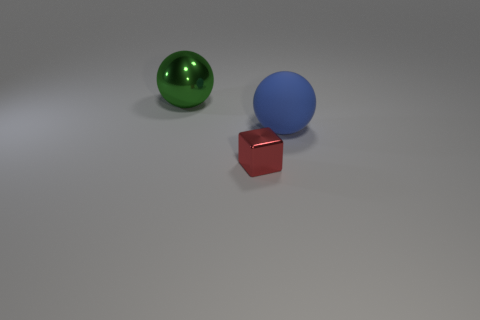What number of green things are large matte objects or big shiny objects?
Offer a very short reply. 1. How many things are both in front of the large metallic object and behind the tiny cube?
Give a very brief answer. 1. Is the material of the red block the same as the green sphere?
Provide a short and direct response. Yes. There is a metallic object that is the same size as the blue ball; what shape is it?
Offer a terse response. Sphere. Are there more tiny cyan metallic objects than green metal spheres?
Offer a very short reply. No. There is a thing that is to the left of the large matte object and behind the block; what material is it?
Provide a succinct answer. Metal. What number of other objects are there of the same material as the large blue sphere?
Offer a terse response. 0. There is a metallic object behind the metal object that is in front of the sphere that is to the left of the rubber thing; how big is it?
Offer a very short reply. Large. What number of matte things are either small red blocks or big red cylinders?
Ensure brevity in your answer.  0. Do the blue matte thing and the object that is behind the blue rubber thing have the same shape?
Your response must be concise. Yes. 